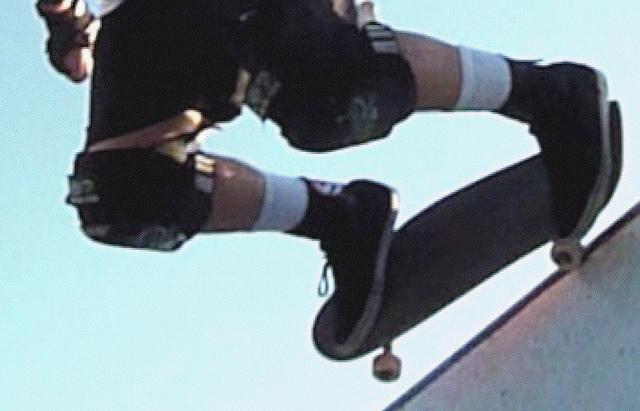What is the person wearing on their knees?
Be succinct. Knee pads. What color are the boy's socks?
Give a very brief answer. White. How many people are on skateboards?
Be succinct. 1. 